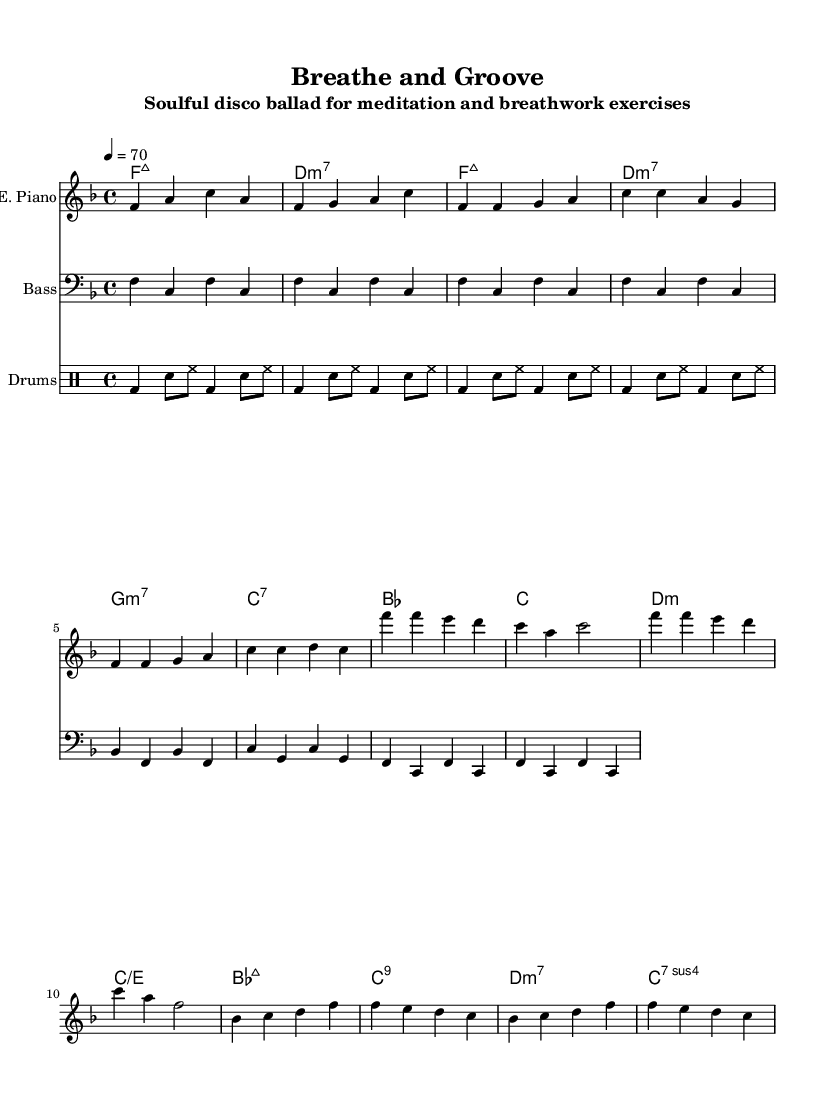What is the key signature of this music? The key signature is indicated at the beginning of the music sheet, showing one flat. This corresponds to the key of F major.
Answer: F major What is the time signature of this music? The time signature is represented by the numbers at the beginning of the sheet music, which are 4 over 4, indicating four beats per measure.
Answer: 4/4 What is the tempo of this piece? The tempo marking is located near the beginning of the music, written as a number and a note value that indicates beats per minute. It shows a tempo of 70 beats per minute.
Answer: 70 How many measures are there in the verse section? By counting the measures in the verse, which starts immediately after the intro and consists of two phrases of four measures each, we find there are 8 measures total.
Answer: 8 What is the primary chord used in the chorus? In the chorus section, the first chord is indicated as B flat major, which is a dominant style chord often used in disco to create energy.
Answer: B flat major How many different instruments are featured in this piece? The music sheet indicates three different parts: one for electric piano, one for bass guitar, and one for drums, thus totaling three instruments.
Answer: Three What rhythmic pattern is used in the drum part? The drum part indicates a consistent repeating pattern which is known as a four-on-the-floor beat, characterized by a bass drum hit on each beat.
Answer: Four-on-the-floor 